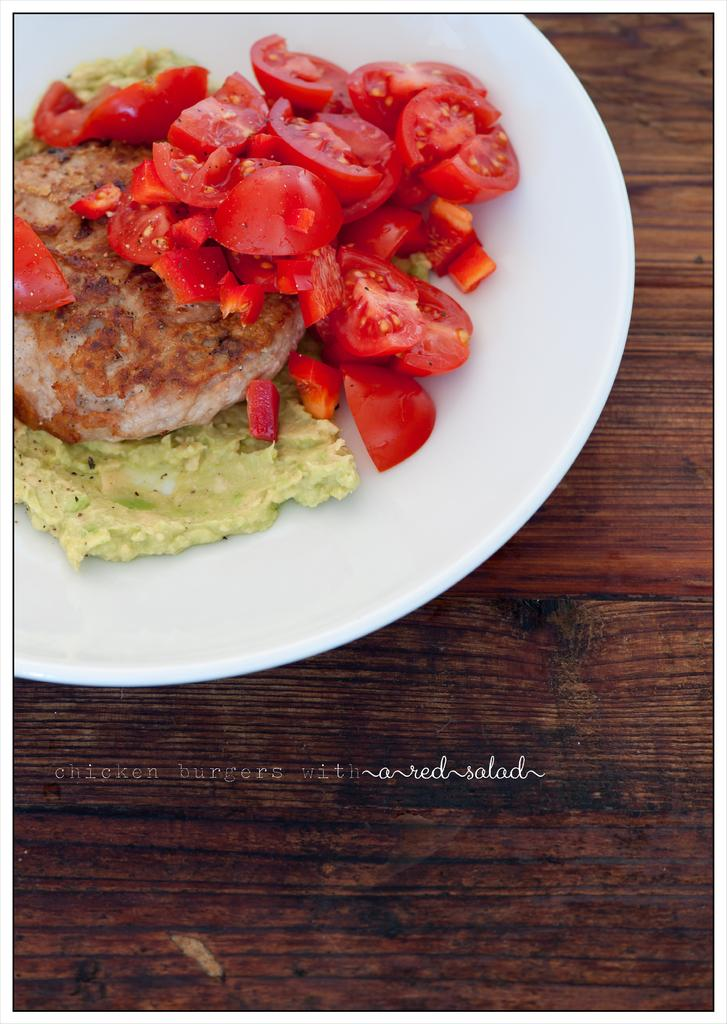What type of food can be seen in the image? There are tomato pieces in the image. Are there any other food items visible besides the tomato pieces? Yes, there are other food items in the image. What color is the plate that holds the food? The plate is white in color. How does the father interact with the tomato pieces in the image? There is no father present in the image, so it is not possible to answer how the father interacts with the tomato pieces. 